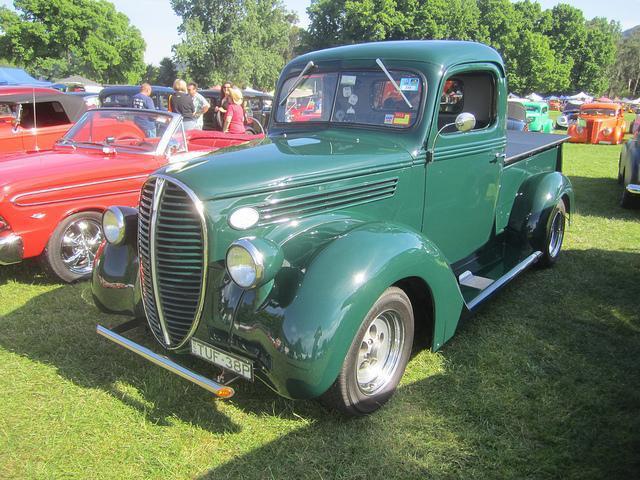How many cars can you see?
Give a very brief answer. 3. How many green-topped spray bottles are there?
Give a very brief answer. 0. 